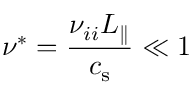<formula> <loc_0><loc_0><loc_500><loc_500>\nu ^ { * } = \frac { \nu _ { i i } L _ { \| } } { { c _ { s } } } \ll 1</formula> 